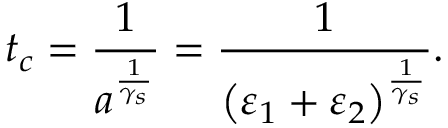<formula> <loc_0><loc_0><loc_500><loc_500>t _ { c } = \frac { 1 } { a ^ { \frac { 1 } { \gamma _ { s } } } } = \frac { 1 } { \left ( \varepsilon _ { 1 } + \varepsilon _ { 2 } \right ) ^ { \frac { 1 } { \gamma _ { s } } } } .</formula> 